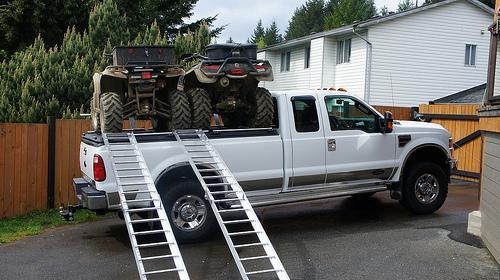How many sport vehicles are there?
Give a very brief answer. 2. 